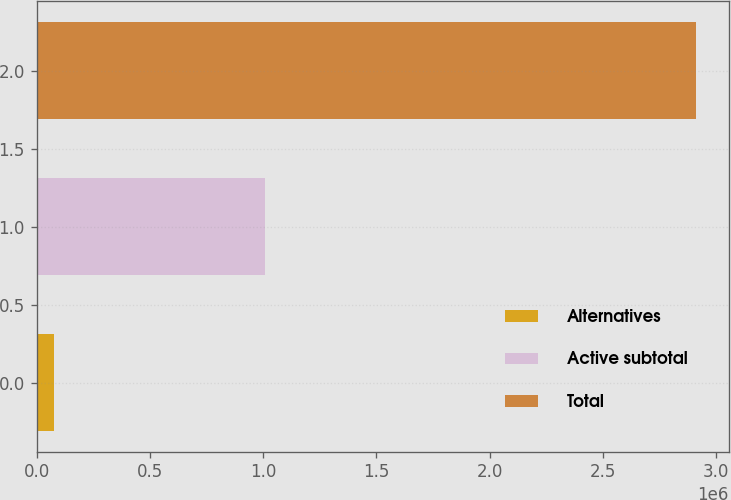Convert chart. <chart><loc_0><loc_0><loc_500><loc_500><bar_chart><fcel>Alternatives<fcel>Active subtotal<fcel>Total<nl><fcel>75615<fcel>1.00997e+06<fcel>2.91166e+06<nl></chart> 